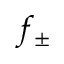<formula> <loc_0><loc_0><loc_500><loc_500>f _ { \pm }</formula> 